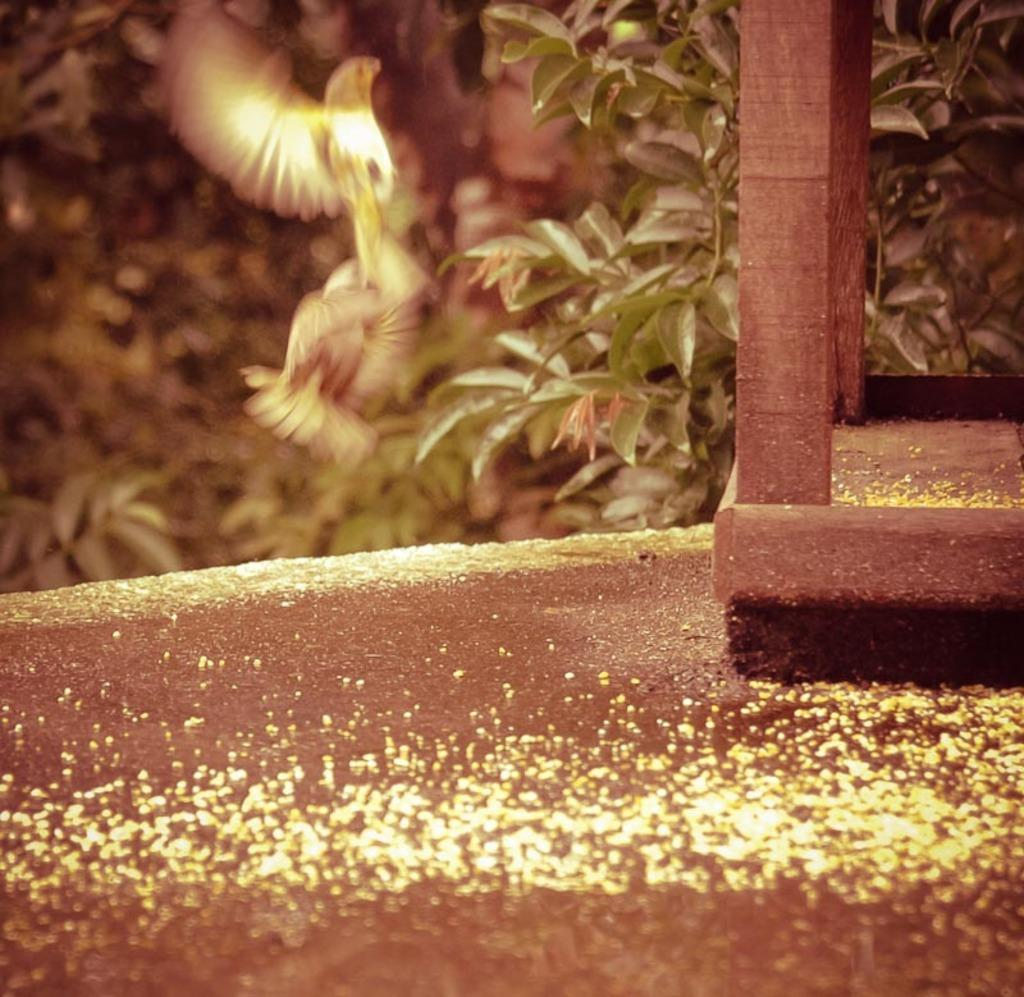What is the bird doing in the image? The bird is flying in the air in the image. What type of object can be seen in the image made of wood? There is a wooden object in the image. What is present on the surface in the image? Seeds are present on the surface in the image. How would you describe the background of the image? The background of the image has a blurred view. What type of vegetation is visible in the image? Plant leaves are visible in the image. What type of pencil is being used to make a statement in the image? There is no pencil or statement present in the image. 